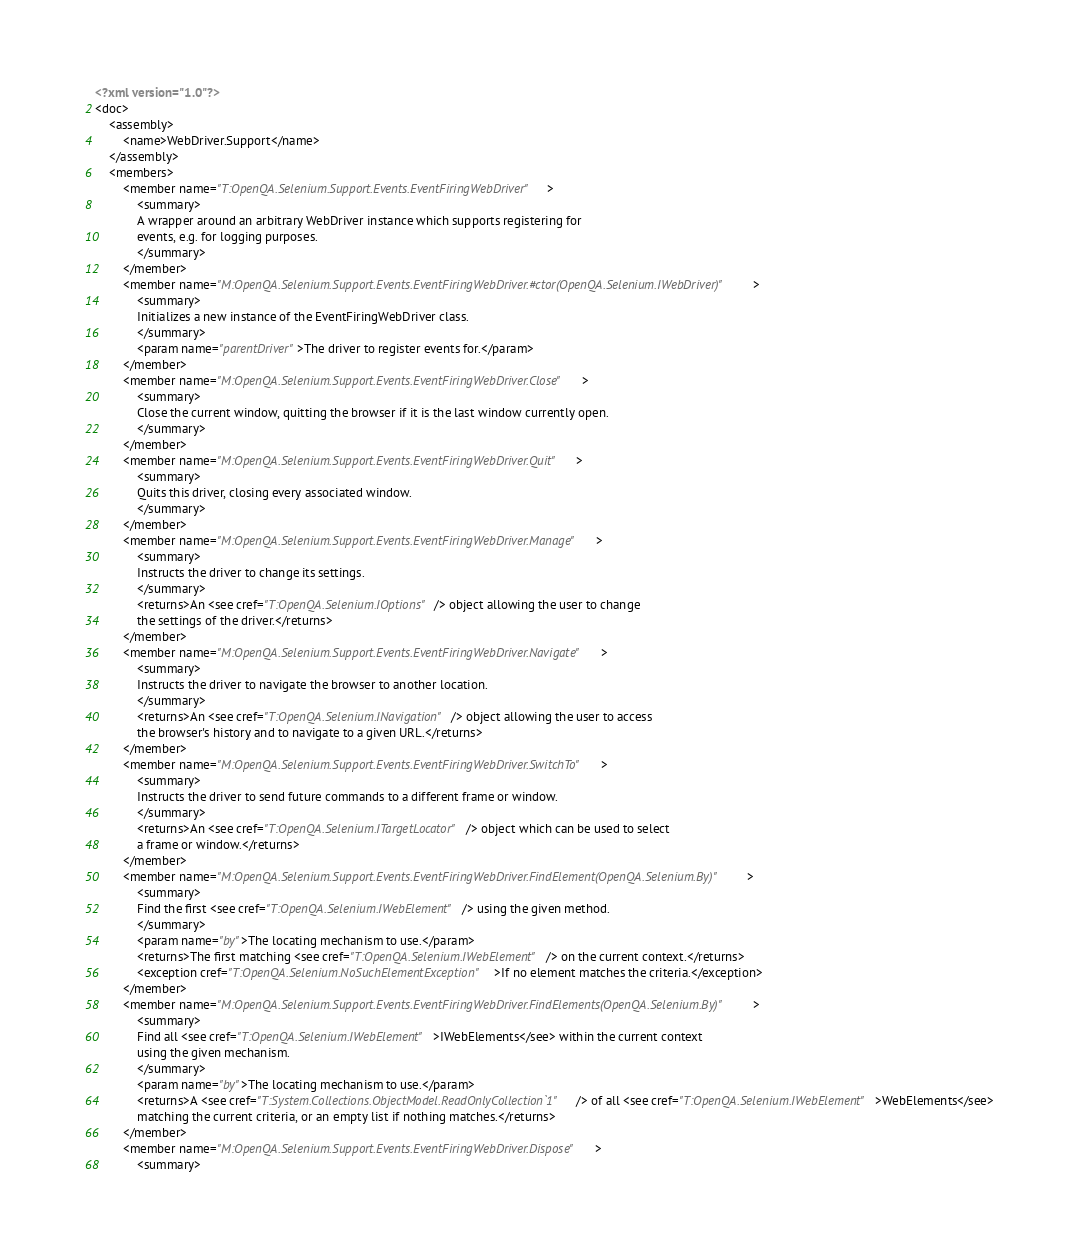Convert code to text. <code><loc_0><loc_0><loc_500><loc_500><_XML_><?xml version="1.0"?>
<doc>
    <assembly>
        <name>WebDriver.Support</name>
    </assembly>
    <members>
        <member name="T:OpenQA.Selenium.Support.Events.EventFiringWebDriver">
            <summary>
            A wrapper around an arbitrary WebDriver instance which supports registering for 
            events, e.g. for logging purposes.
            </summary>
        </member>
        <member name="M:OpenQA.Selenium.Support.Events.EventFiringWebDriver.#ctor(OpenQA.Selenium.IWebDriver)">
            <summary>
            Initializes a new instance of the EventFiringWebDriver class.
            </summary>
            <param name="parentDriver">The driver to register events for.</param>
        </member>
        <member name="M:OpenQA.Selenium.Support.Events.EventFiringWebDriver.Close">
            <summary>
            Close the current window, quitting the browser if it is the last window currently open.
            </summary>
        </member>
        <member name="M:OpenQA.Selenium.Support.Events.EventFiringWebDriver.Quit">
            <summary>
            Quits this driver, closing every associated window.
            </summary>
        </member>
        <member name="M:OpenQA.Selenium.Support.Events.EventFiringWebDriver.Manage">
            <summary>
            Instructs the driver to change its settings.
            </summary>
            <returns>An <see cref="T:OpenQA.Selenium.IOptions"/> object allowing the user to change
            the settings of the driver.</returns>
        </member>
        <member name="M:OpenQA.Selenium.Support.Events.EventFiringWebDriver.Navigate">
            <summary>
            Instructs the driver to navigate the browser to another location.
            </summary>
            <returns>An <see cref="T:OpenQA.Selenium.INavigation"/> object allowing the user to access 
            the browser's history and to navigate to a given URL.</returns>
        </member>
        <member name="M:OpenQA.Selenium.Support.Events.EventFiringWebDriver.SwitchTo">
            <summary>
            Instructs the driver to send future commands to a different frame or window.
            </summary>
            <returns>An <see cref="T:OpenQA.Selenium.ITargetLocator"/> object which can be used to select
            a frame or window.</returns>
        </member>
        <member name="M:OpenQA.Selenium.Support.Events.EventFiringWebDriver.FindElement(OpenQA.Selenium.By)">
            <summary>
            Find the first <see cref="T:OpenQA.Selenium.IWebElement"/> using the given method. 
            </summary>
            <param name="by">The locating mechanism to use.</param>
            <returns>The first matching <see cref="T:OpenQA.Selenium.IWebElement"/> on the current context.</returns>
            <exception cref="T:OpenQA.Selenium.NoSuchElementException">If no element matches the criteria.</exception>
        </member>
        <member name="M:OpenQA.Selenium.Support.Events.EventFiringWebDriver.FindElements(OpenQA.Selenium.By)">
            <summary>
            Find all <see cref="T:OpenQA.Selenium.IWebElement">IWebElements</see> within the current context 
            using the given mechanism.
            </summary>
            <param name="by">The locating mechanism to use.</param>
            <returns>A <see cref="T:System.Collections.ObjectModel.ReadOnlyCollection`1"/> of all <see cref="T:OpenQA.Selenium.IWebElement">WebElements</see>
            matching the current criteria, or an empty list if nothing matches.</returns>
        </member>
        <member name="M:OpenQA.Selenium.Support.Events.EventFiringWebDriver.Dispose">
            <summary></code> 